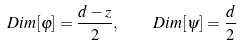<formula> <loc_0><loc_0><loc_500><loc_500>D i m [ \varphi ] = \frac { d - z } 2 , \quad D i m [ \psi ] = \frac { d } 2</formula> 